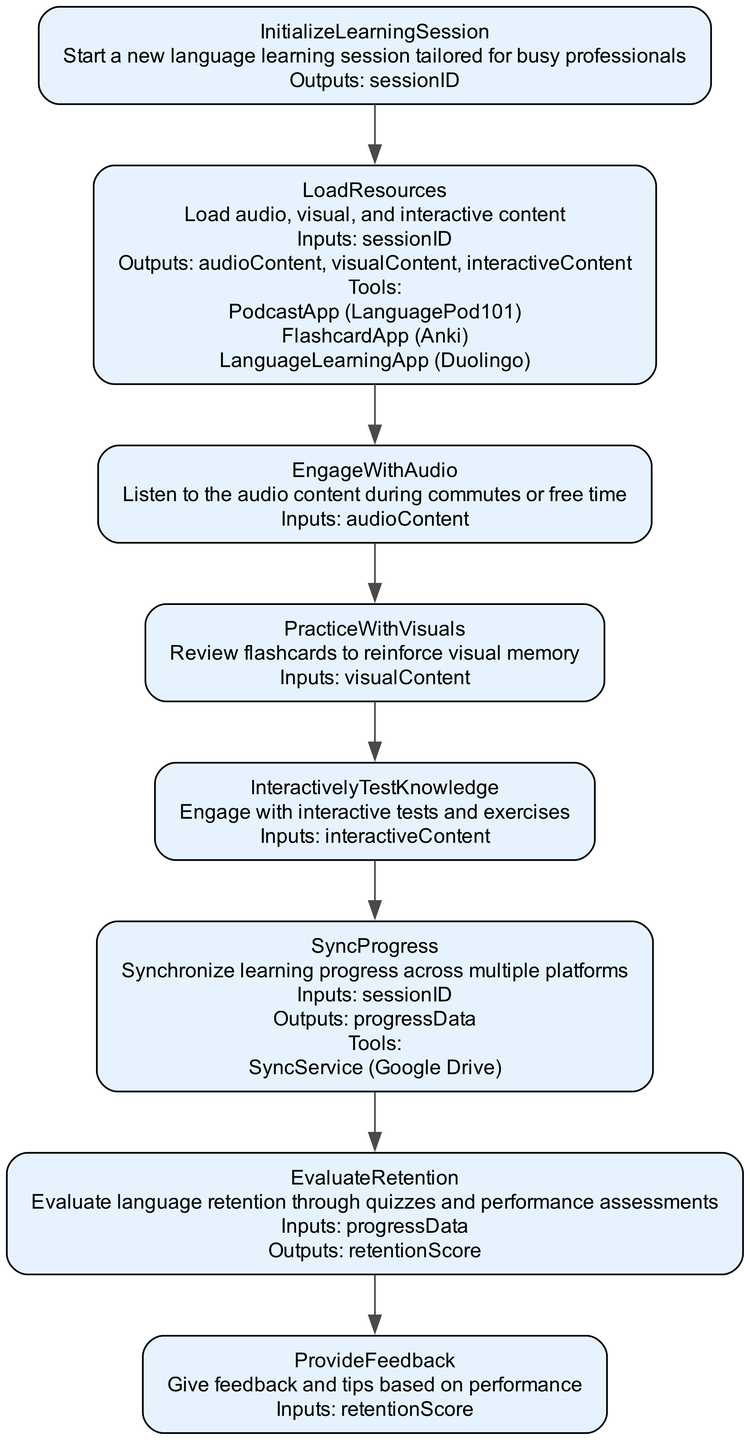What is the name of the function in the diagram? The function name is clearly labeled as "EffectiveLanguageRetention" at the beginning of the diagram.
Answer: EffectiveLanguageRetention How many steps are there in this flowchart? By counting the number of steps listed in the diagram, there are a total of eight steps involved in the function's process.
Answer: 8 What is the output of the step "SyncProgress"? The output of the "SyncProgress" step is "progressData," as indicated directly in the outputs section of that node.
Answer: progressData Which step involves listening to audio content? The step "EngageWithAudio" specifically describes the action of listening to audio content during commutes or free time, making it the correct answer.
Answer: EngageWithAudio What tools are used in the "LoadResources" step? The "LoadResources" step lists three tools: "PodcastApp," "FlashcardApp," and "LanguageLearningApp" as resources for the input of the learning session.
Answer: PodcastApp, FlashcardApp, LanguageLearningApp What is the final output of the function process? The final output of the function process is "retentionScore," which is obtained after the "EvaluateRetention" step according to the flow of the diagram.
Answer: retentionScore What does the "ProvideFeedback" step take as input? The input to the "ProvideFeedback" step is "retentionScore," which is derived from the previous step evaluating retention through quizzes and performance assessments.
Answer: retentionScore What is the relationship between "EvaluateRetention" and "ProvideFeedback"? The connection between "EvaluateRetention" and "ProvideFeedback" is sequential, where "EvaluateRetention" outputs "retentionScore," which serves as the input for "ProvideFeedback."
Answer: Sequential connection 